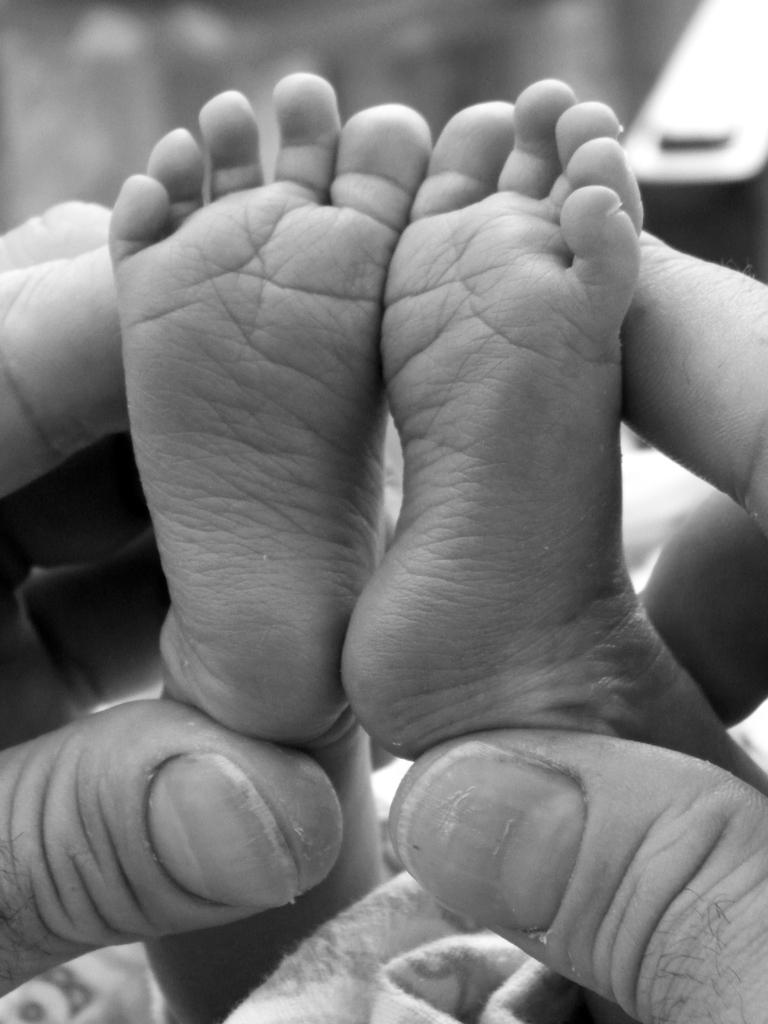Who or what is the main subject in the image? There is a person in the image. What is the person doing in the image? The person's hands are holding the legs of a small baby. What type of range can be seen in the background of the image? There is no range present in the image; it only features a person holding a small baby. 